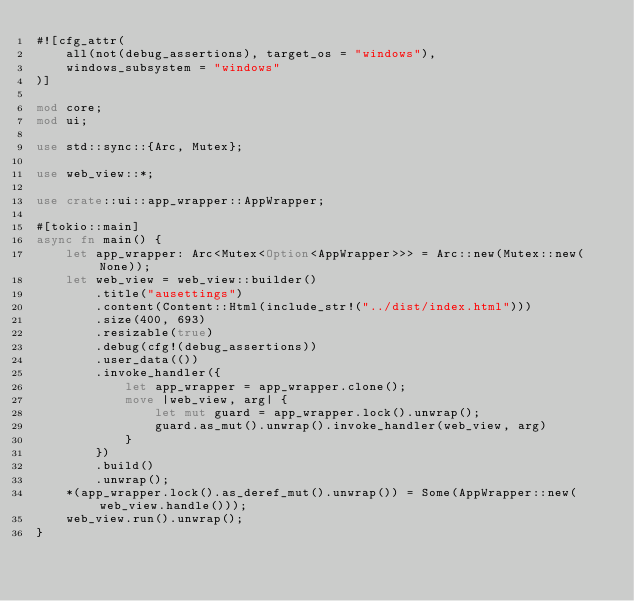Convert code to text. <code><loc_0><loc_0><loc_500><loc_500><_Rust_>#![cfg_attr(
    all(not(debug_assertions), target_os = "windows"),
    windows_subsystem = "windows"
)]

mod core;
mod ui;

use std::sync::{Arc, Mutex};

use web_view::*;

use crate::ui::app_wrapper::AppWrapper;

#[tokio::main]
async fn main() {
    let app_wrapper: Arc<Mutex<Option<AppWrapper>>> = Arc::new(Mutex::new(None));
    let web_view = web_view::builder()
        .title("ausettings")
        .content(Content::Html(include_str!("../dist/index.html")))
        .size(400, 693)
        .resizable(true)
        .debug(cfg!(debug_assertions))
        .user_data(())
        .invoke_handler({
            let app_wrapper = app_wrapper.clone();
            move |web_view, arg| {
                let mut guard = app_wrapper.lock().unwrap();
                guard.as_mut().unwrap().invoke_handler(web_view, arg)
            }
        })
        .build()
        .unwrap();
    *(app_wrapper.lock().as_deref_mut().unwrap()) = Some(AppWrapper::new(web_view.handle()));
    web_view.run().unwrap();
}
</code> 